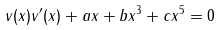Convert formula to latex. <formula><loc_0><loc_0><loc_500><loc_500>v ( x ) v ^ { \prime } ( x ) + a x + b x ^ { 3 } + c x ^ { 5 } = 0</formula> 